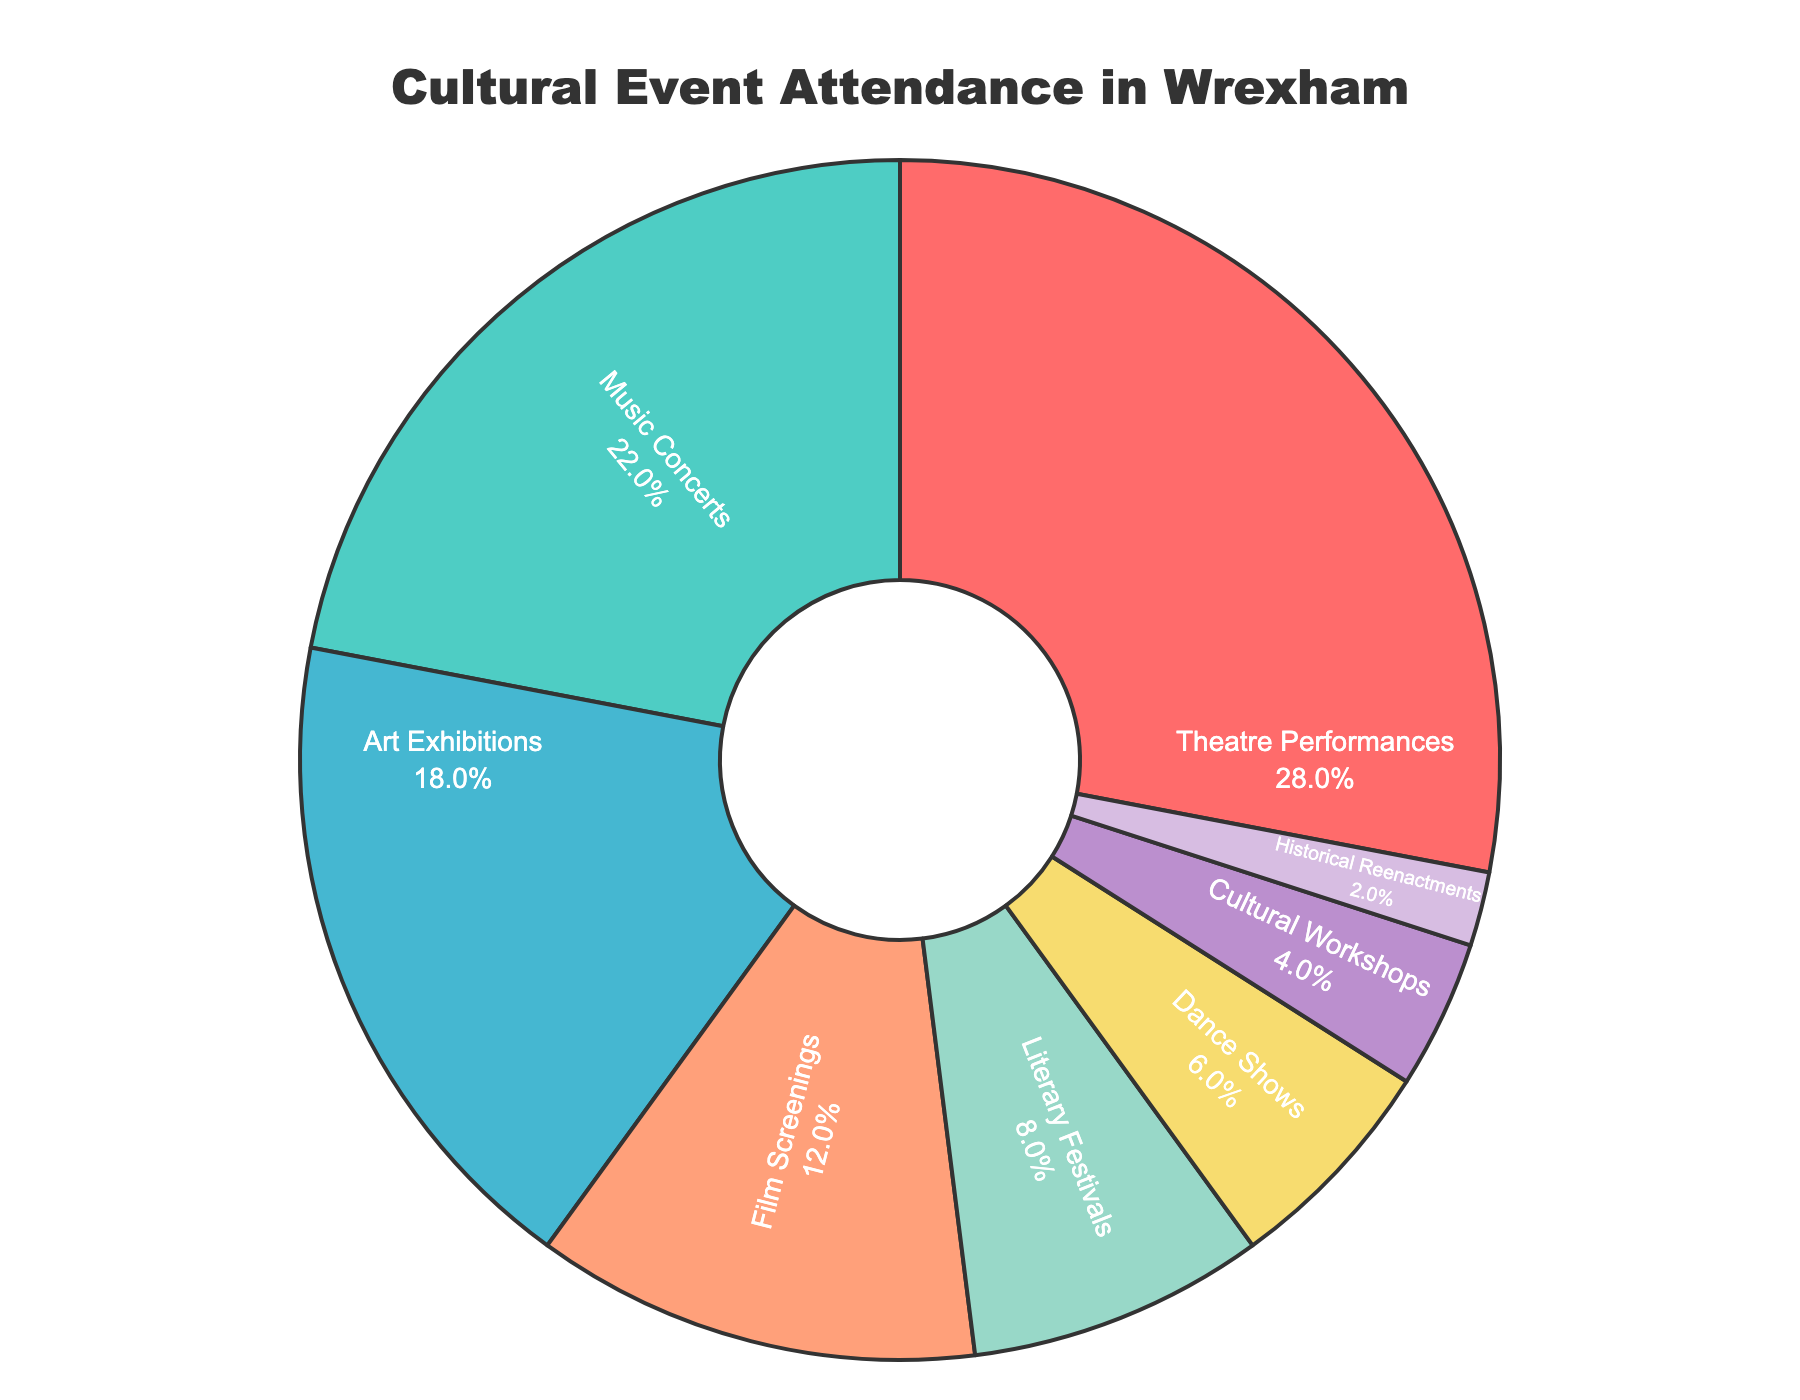What's the total percentage of attendance for Theatre Performances, Music Concerts, and Art Exhibitions combined? To find the combined percentage for these three event types, add their individual percentages together: 28% (Theatre Performances) + 22% (Music Concerts) + 18% (Art Exhibitions) = 68%.
Answer: 68% Which event type has the lowest attendance percentage? Look for the smallest percentage value in the pie chart. Historical Reenactments have the lowest attendance at 2%.
Answer: Historical Reenactments Is the attendance for Dance Shows more than twice the attendance for Cultural Workshops? Compare the percentages for Dance Shows (6%) and Cultural Workshops (4%). Twice the attendance for Cultural Workshops would be 4% * 2 = 8%. Since 6% < 8%, the attendance for Dance Shows is not more than twice that of Cultural Workshops.
Answer: No Between Theatre Performances and Film Screenings, which has a higher attendance percentage and by how much? Compare the percentages for Theatre Performances (28%) and Film Screenings (12%). The difference is 28% - 12% = 16%.
Answer: Theatre Performances by 16% What percentage of event attendance does the combination of Cultural Workshops and Historical Reenactments represent? Sum the percentages for Cultural Workshops (4%) and Historical Reenactments (2%): 4% + 2% = 6%.
Answer: 6% If you combine the attendance percentages of Literary Festivals and Dance Shows, do they exceed the attendance for Art Exhibitions? Sum the percentages of Literary Festivals (8%) and Dance Shows (6%): 8% + 6% = 14%. Compare this with the percentage for Art Exhibitions (18%). Since 14% < 18%, the combined attendance does not exceed the attendance for Art Exhibitions.
Answer: No Identify the event type with the second highest attendance percentage. The second highest attendance percentage is 22%, which corresponds to Music Concerts.
Answer: Music Concerts How much more popular are Music Concerts compared to Film Screenings in percentage terms? Subtract the percentage of Film Screenings (12%) from Music Concerts (22%): 22% - 12% = 10%.
Answer: 10% What is the combined percentage attendance of the two least popular event types? Identify the two least popular event types: Cultural Workshops (4%) and Historical Reenactments (2%). Sum their percentages: 4% + 2% = 6%.
Answer: 6% Do the top three event types in terms of attendance percentage account for more than half of all event attendance? Sum the percentages of the top three event types: Theatre Performances (28%), Music Concerts (22%), and Art Exhibitions (18%). Combined, they are: 28% + 22% + 18% = 68%, which is more than half (50%).
Answer: Yes 